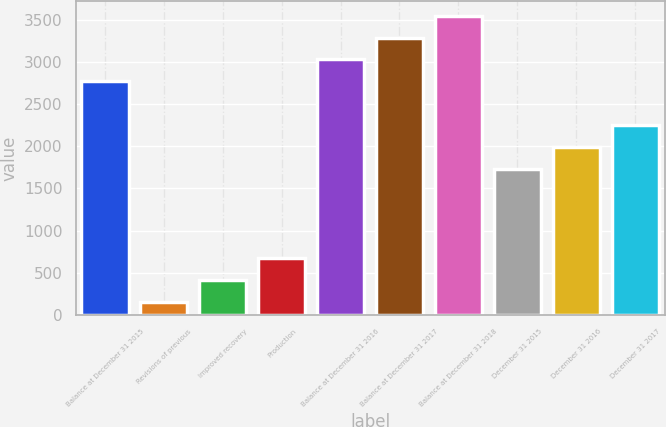Convert chart to OTSL. <chart><loc_0><loc_0><loc_500><loc_500><bar_chart><fcel>Balance at December 31 2015<fcel>Revisions of previous<fcel>Improved recovery<fcel>Production<fcel>Balance at December 31 2016<fcel>Balance at December 31 2017<fcel>Balance at December 31 2018<fcel>December 31 2015<fcel>December 31 2016<fcel>December 31 2017<nl><fcel>2769.2<fcel>159<fcel>418.3<fcel>677.6<fcel>3028.5<fcel>3287.8<fcel>3547.1<fcel>1732<fcel>1991.3<fcel>2250.6<nl></chart> 